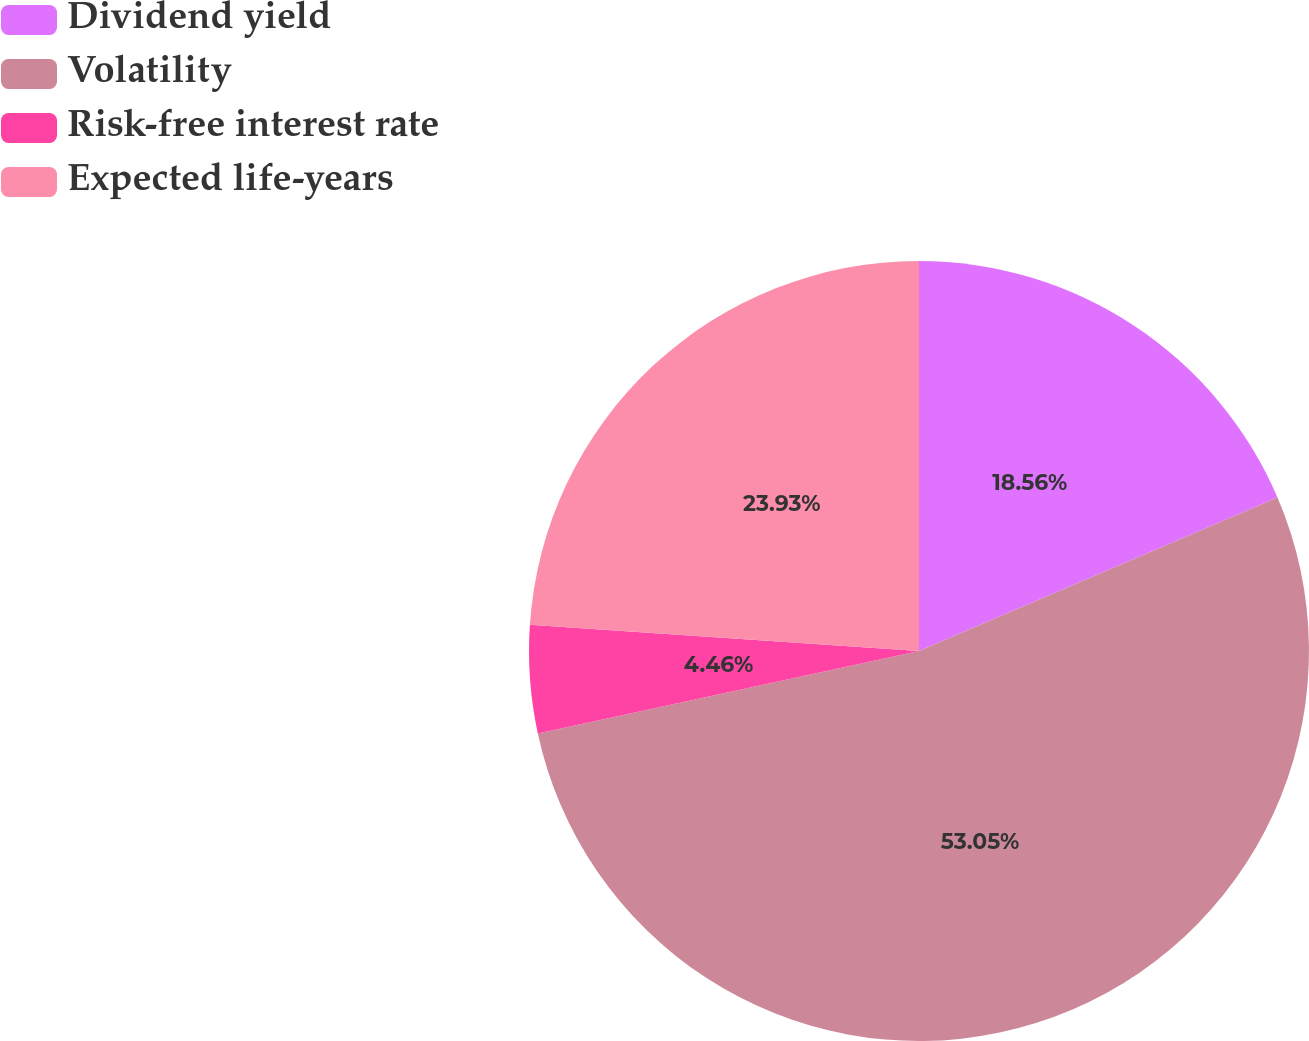<chart> <loc_0><loc_0><loc_500><loc_500><pie_chart><fcel>Dividend yield<fcel>Volatility<fcel>Risk-free interest rate<fcel>Expected life-years<nl><fcel>18.56%<fcel>53.05%<fcel>4.46%<fcel>23.93%<nl></chart> 